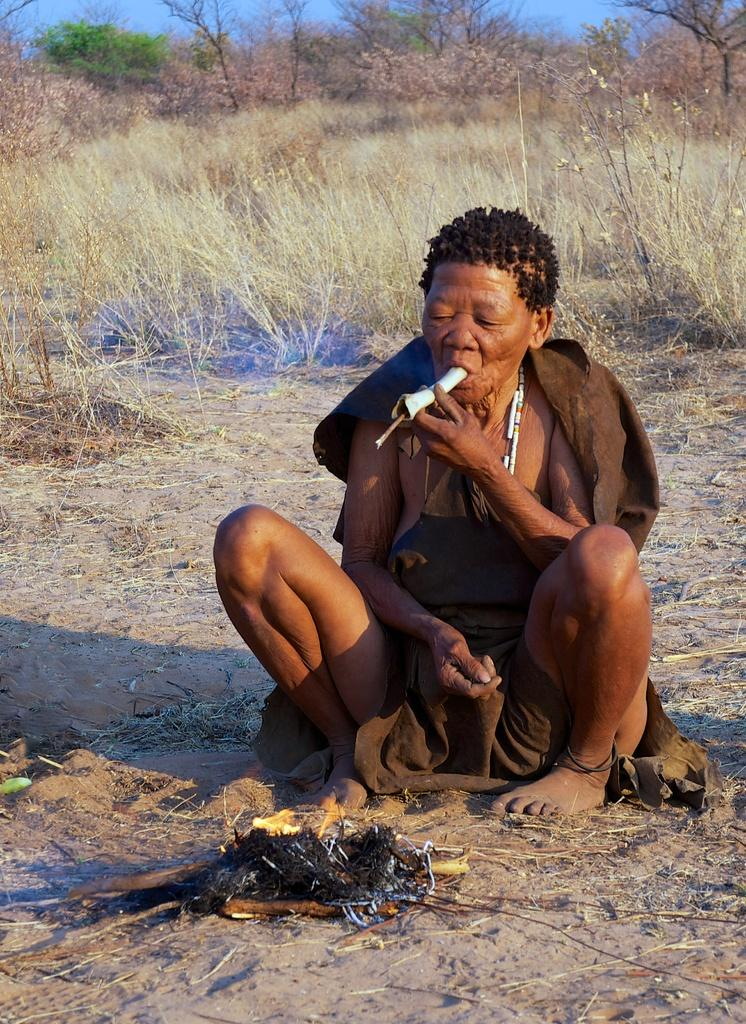What is the person in the image doing? The person is sitting and holding an object with their mouth and hand. Can you describe the object the person is holding? Unfortunately, the object cannot be identified from the image. What type of terrain is visible in the image? There is sand visible in the image, as well as grass in the background. What is the source of light in the image? There is fire in the image, which could be the source of light. What can be seen in the sky in the image? The sky is visible in the background of the image. What type of oil is being used to extinguish the fire in the image? There is no oil present in the image, and the fire is not being extinguished. 